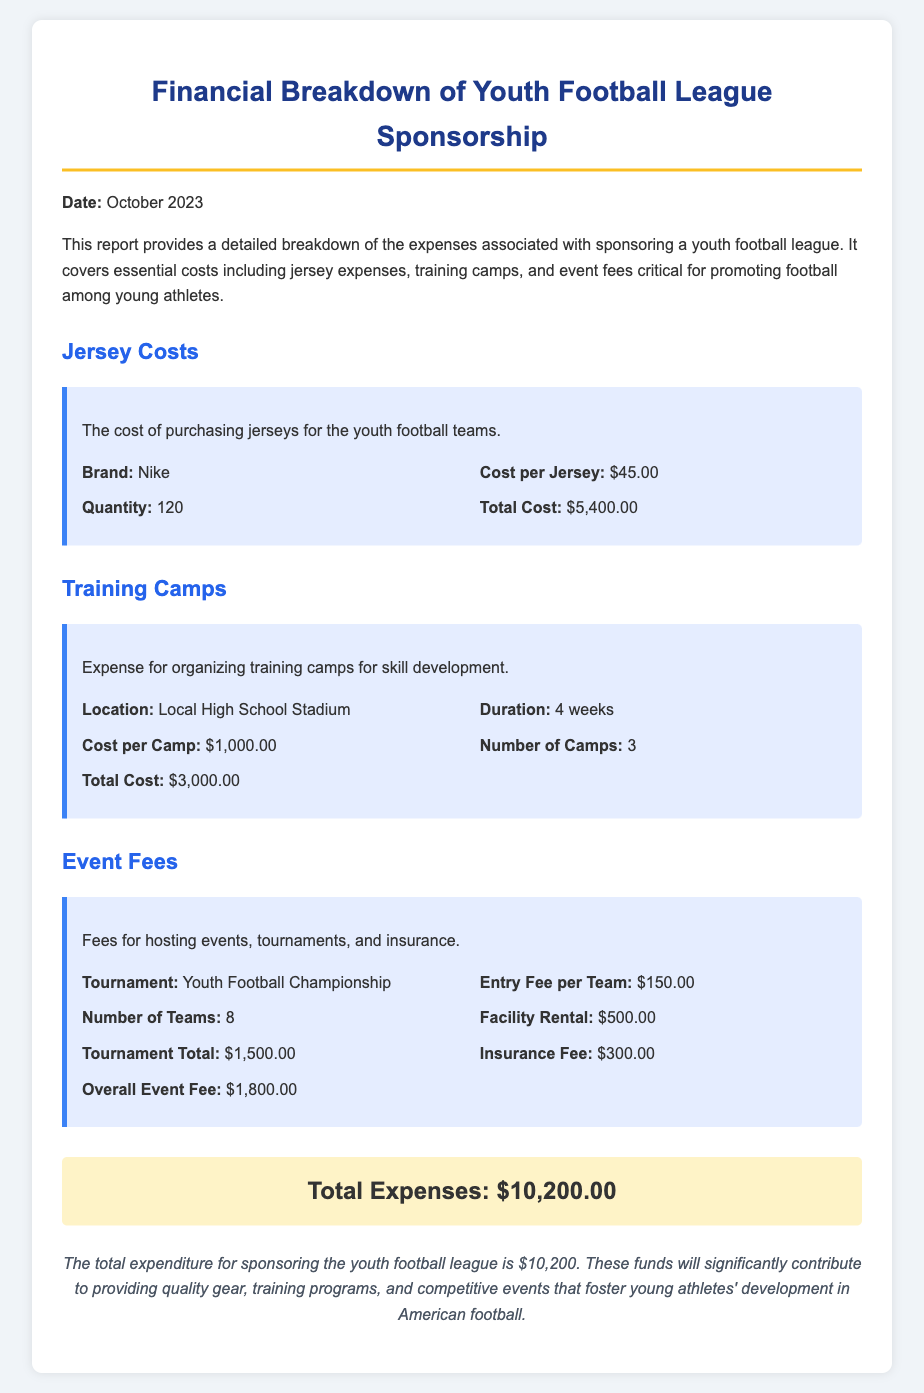What is the total cost of jerseys? The total cost of jerseys is provided in the jersey costs section as $5,400.00.
Answer: $5,400.00 How many jerseys were purchased? The document states the quantity of jerseys purchased is 120.
Answer: 120 What is the cost per camp? The cost per camp is mentioned in the training camps section as $1,000.00.
Answer: $1,000.00 How many training camps were organized? According to the report, there were 3 training camps organized.
Answer: 3 What is the overall event fee? The overall event fee is clearly stated in the event fees section as $1,800.00.
Answer: $1,800.00 What is the total expenditure for the youth football league? The total expenditure is summarized in the document as $10,200.00.
Answer: $10,200.00 What brand are the jerseys from? The document specifies that the jerseys are from Nike.
Answer: Nike What is the entry fee per team for the tournament? The entry fee per team is listed as $150.00.
Answer: $150.00 What was the location of the training camps? The training camps were held at the Local High School Stadium.
Answer: Local High School Stadium 